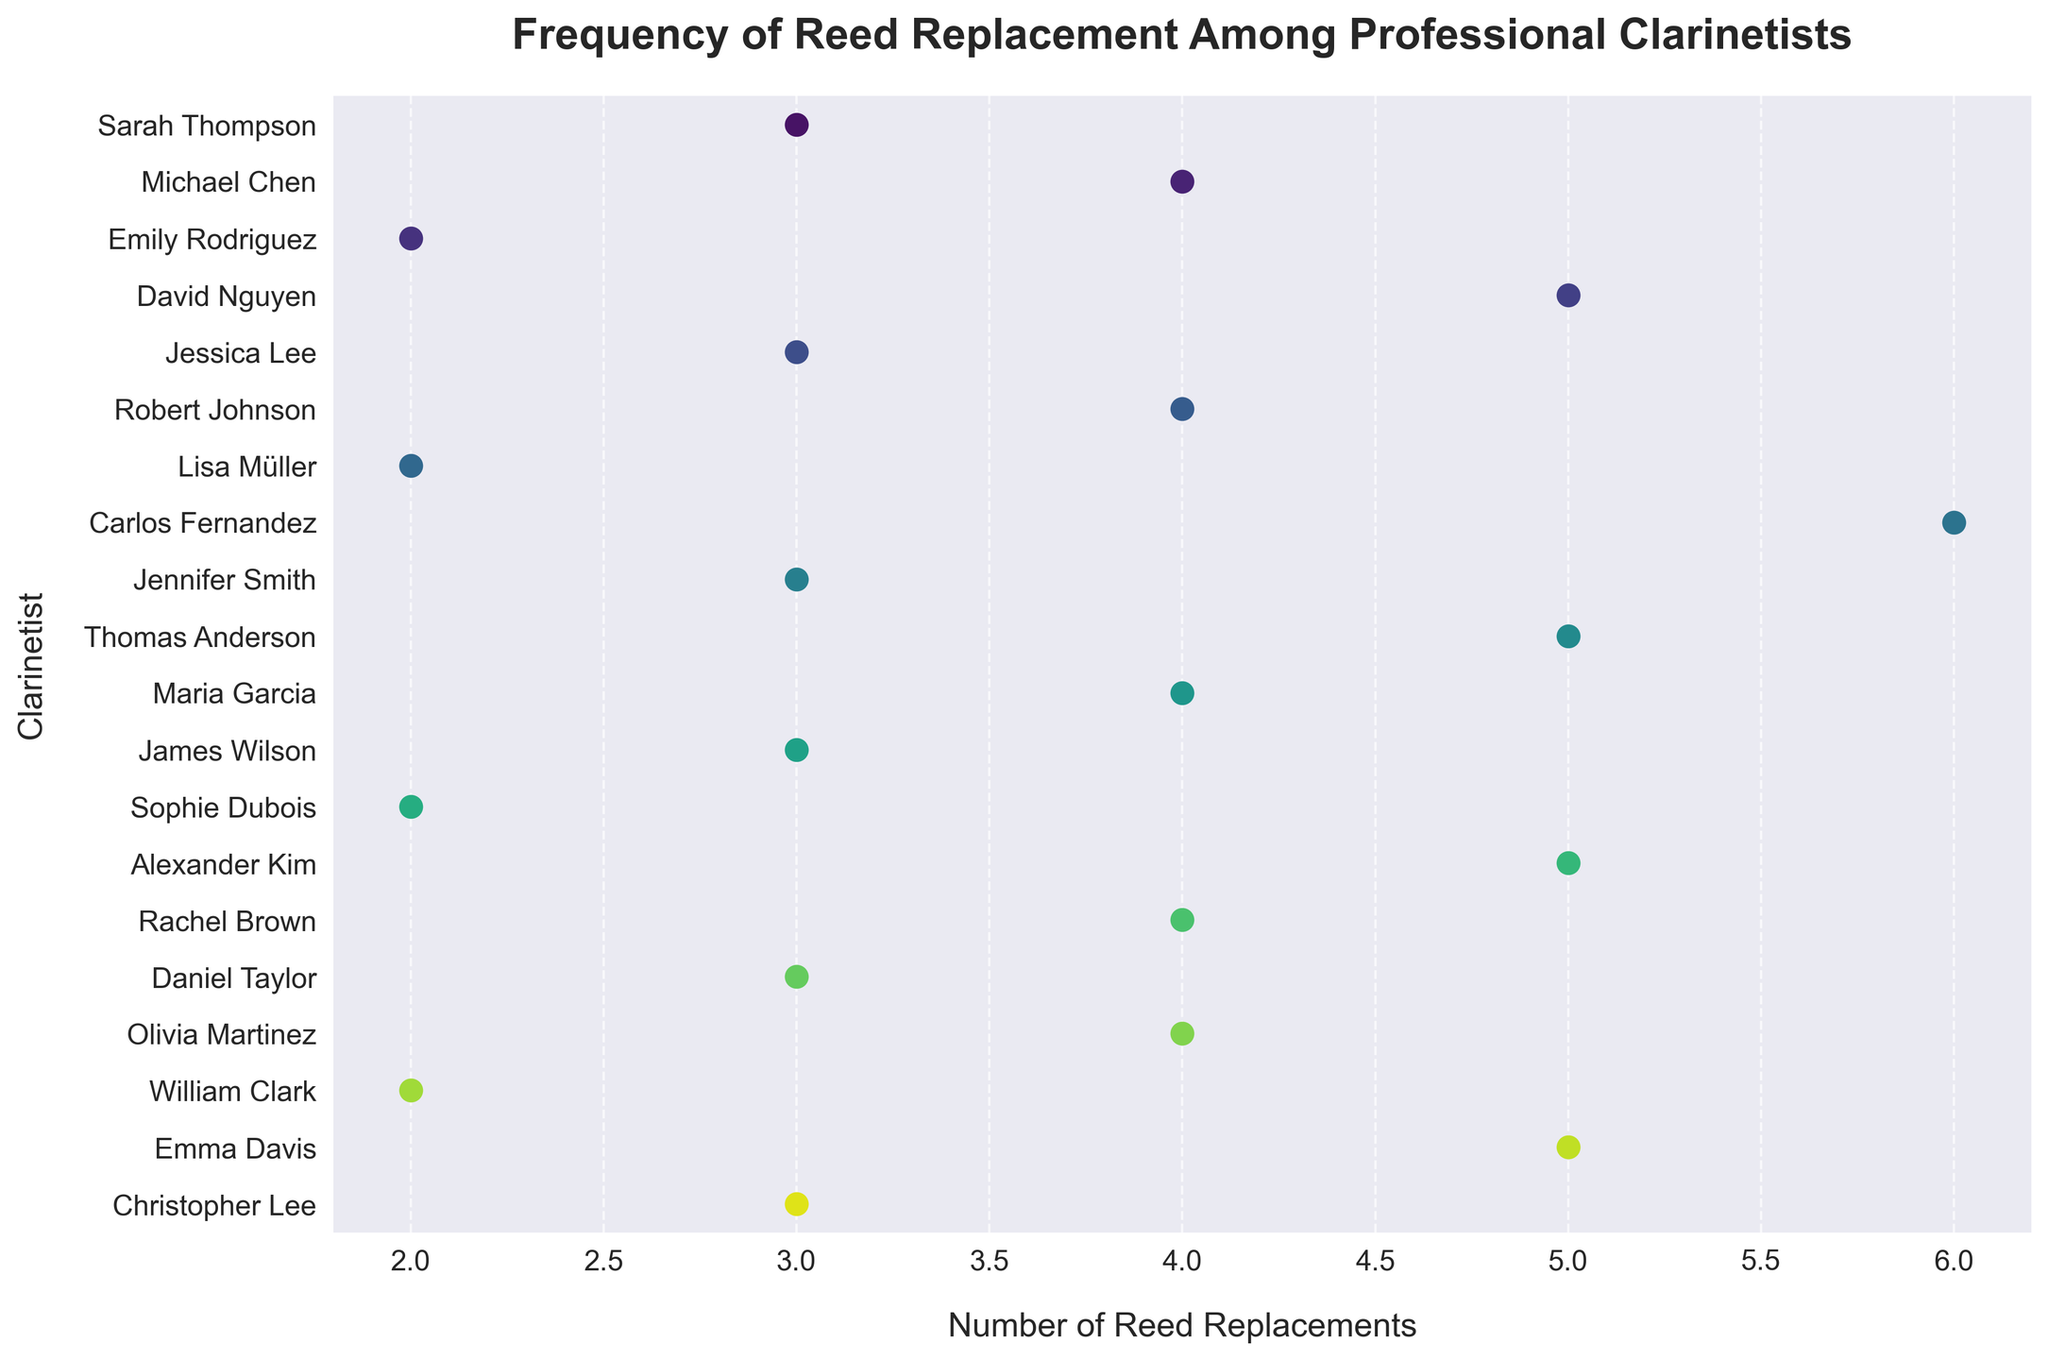What is the title of the figure? The title is usually the most prominent text at the top of the figure that describes the overall content. In this case, it reads 'Frequency of Reed Replacement Among Professional Clarinetists'.
Answer: Frequency of Reed Replacement Among Professional Clarinetists How many clarinetists replaced their reeds exactly 3 times during the concert season? Count the number of data points in the plot that correspond to 3 reed replacements. Each point represents a clarinetist.
Answer: 6 Which clarinetist had the highest number of reed replacements, and how many times did they replace it? Identify the data point farthest to the right. The name associated with this point shows who replaced their reeds the most. In this case, it's Carlos Fernandez.
Answer: Carlos Fernandez, 6 What is the average number of reed replacements among all clarinetists? Add up all the reed replacements and divide by the number of clarinetists. (3+4+2+5+3+4+2+6+3+5+4+3+2+5+4+3+4+2+5+3) / 20 = 74 / 20 = 3.7
Answer: 3.7 How many times did Lisa Müller replace her reeds? Locate the player 'Lisa Müller' on the y-axis and see the value corresponding to that point on the x-axis.
Answer: 2 Compare the number of reed replacements between Michael Chen and Jacob Wilson. Who replaced reeds more frequently? Look at the points corresponding to Michael Chen and Jacob Wilson on the vertical axis and compare their positions on the horizontal axis. Michael Chen replaced reeds 4 times, and Jacob Wilson replaced them 3 times.
Answer: Michael Chen How many clarinetists replaced their reeds 4 times? Referring to the data points at 4 reed replacements, count the number of points.
Answer: 5 What is the median number of reed replacements among professional clarinetists? Median is the middle value when the data points are ordered from least to greatest. First, organize the reed replacement numbers: 2, 2, 2, 2, 3, 3, 3, 3, 3, 3, 4, 4, 4, 4, 4, 5, 5, 5, 5, 6. As there are 20 clarinetists, the median is the average of the 10th and 11th values, which are both 3 and 4: (3+4)/2 = 3.5
Answer: 3.5 